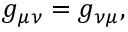Convert formula to latex. <formula><loc_0><loc_0><loc_500><loc_500>g _ { \mu \nu } = g _ { \nu \mu } ,</formula> 